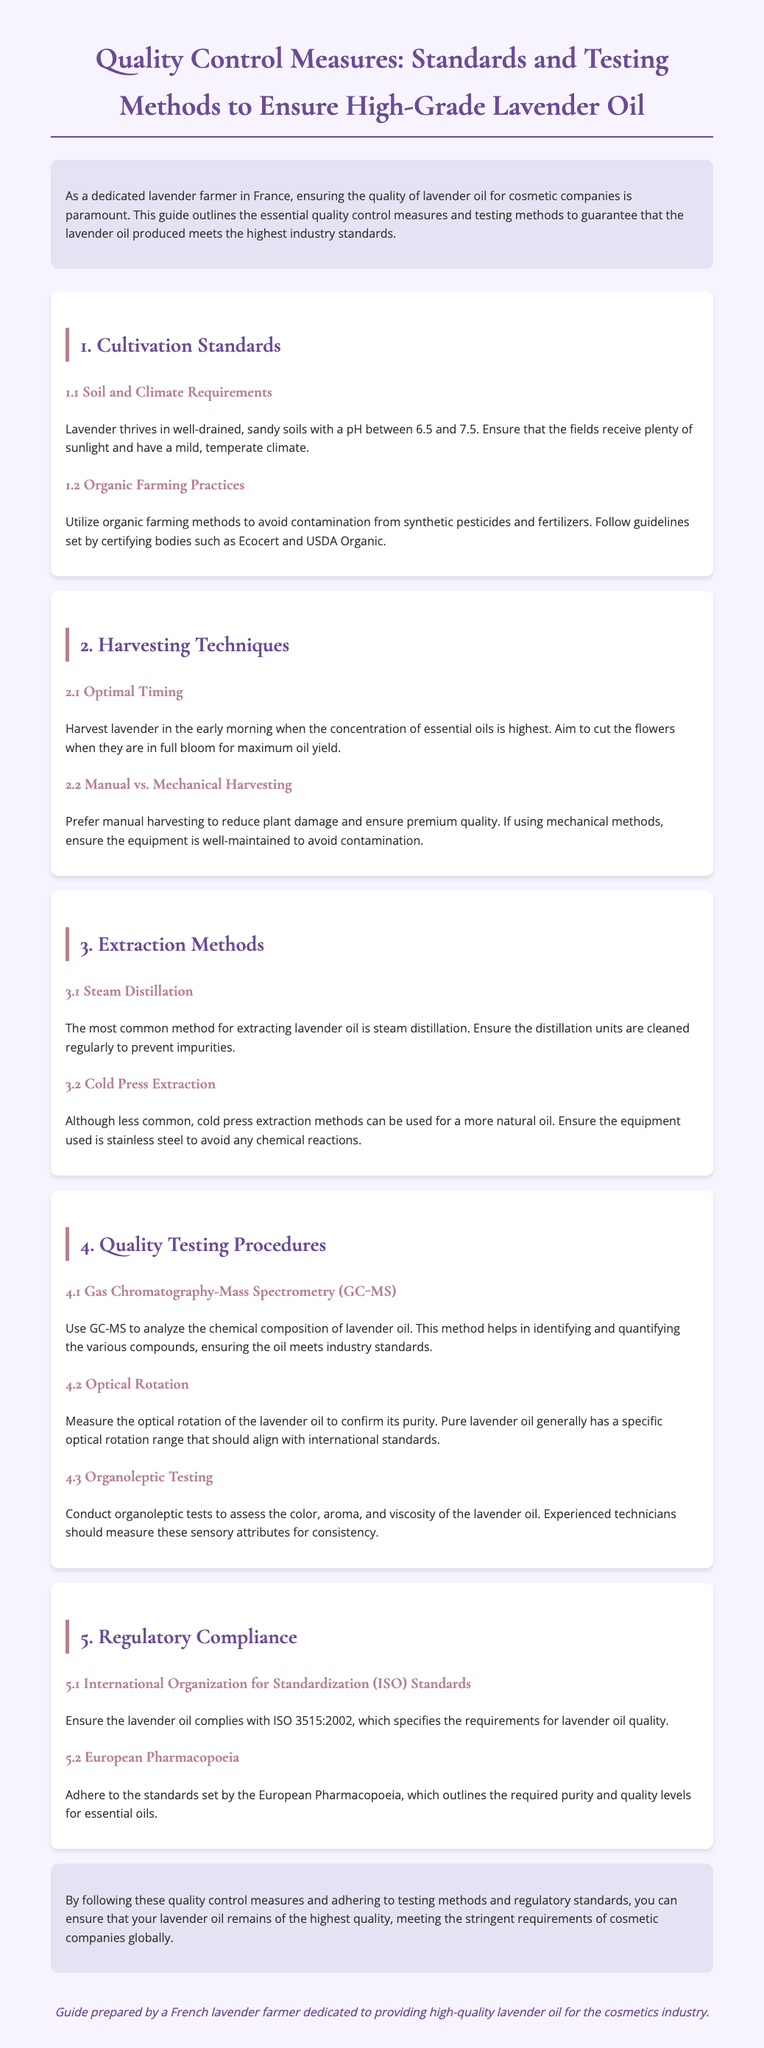what is the pH range for lavender soil? The pH range for lavender soil is specified in the section on soil and climate requirements, which indicates it should be between 6.5 and 7.5.
Answer: 6.5 to 7.5 which harvesting method is preferred for premium quality? The document states that manual harvesting is preferred to reduce plant damage and ensure premium quality.
Answer: Manual harvesting what is the main extraction method mentioned? The main extraction method for lavender oil highlighted in the document is steam distillation.
Answer: Steam distillation what testing method analyzes chemical composition? The method used to analyze the chemical composition of lavender oil is mentioned as Gas Chromatography-Mass Spectrometry (GC-MS).
Answer: GC-MS which organization sets the ISO standards? The document refers to the International Organization for Standardization (ISO) in the section on regulatory compliance.
Answer: International Organization for Standardization what does organoleptic testing assess? Organoleptic testing is noted in the document to assess color, aroma, and viscosity of the lavender oil.
Answer: Color, aroma, and viscosity which certifying bodies should organic practices follow? The organic farming practices should follow guidelines set by Ecocert and USDA Organic, as per the requirements outlined in the document.
Answer: Ecocert and USDA Organic what is the compliance standard for lavender oil quality? The document states that lavender oil should comply with ISO 3515:2002, which specifies requirements for lavender oil quality.
Answer: ISO 3515:2002 